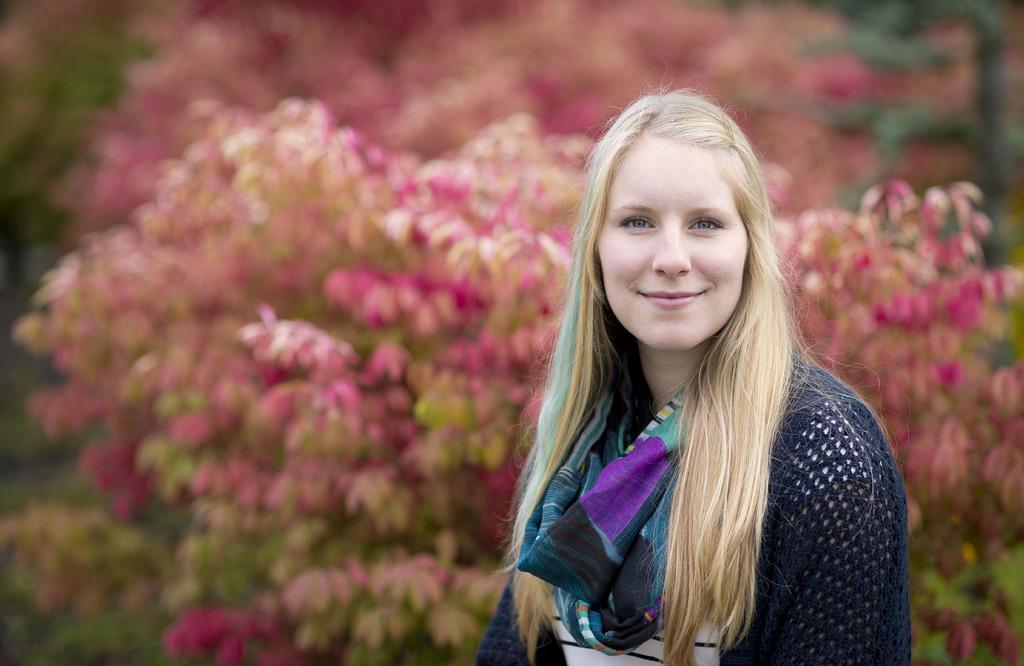Please provide a concise description of this image. In this image in the front there is a woman smiling and in the background there are flowers. 